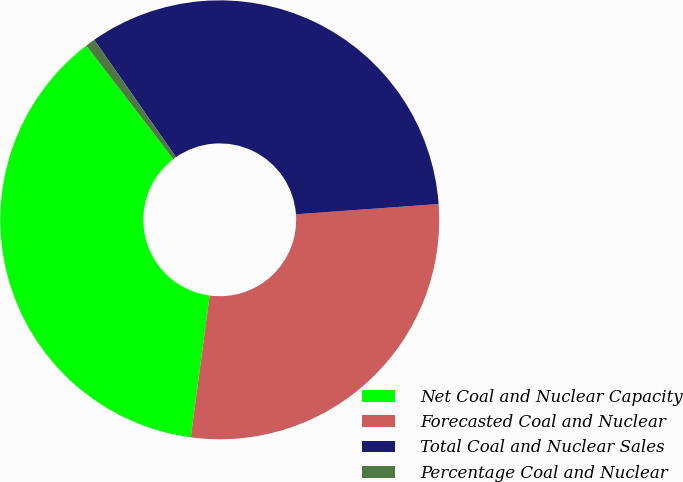Convert chart to OTSL. <chart><loc_0><loc_0><loc_500><loc_500><pie_chart><fcel>Net Coal and Nuclear Capacity<fcel>Forecasted Coal and Nuclear<fcel>Total Coal and Nuclear Sales<fcel>Percentage Coal and Nuclear<nl><fcel>37.49%<fcel>28.25%<fcel>33.55%<fcel>0.71%<nl></chart> 